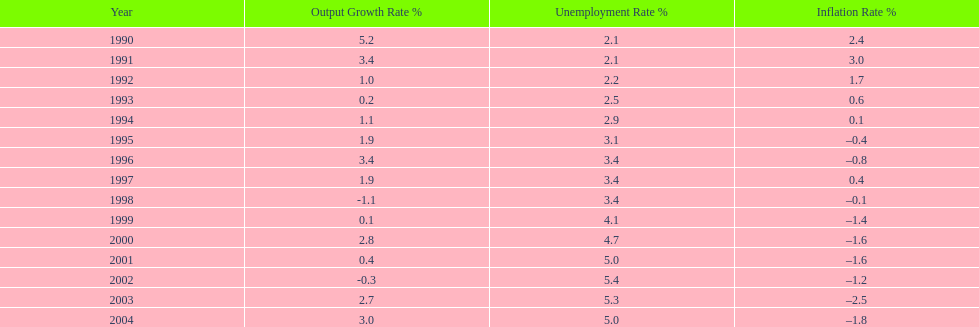What year saw the highest output growth rate in japan between the years 1990 and 2004? 1990. Parse the table in full. {'header': ['Year', 'Output Growth Rate\xa0%', 'Unemployment Rate\xa0%', 'Inflation Rate\xa0%'], 'rows': [['1990', '5.2', '2.1', '2.4'], ['1991', '3.4', '2.1', '3.0'], ['1992', '1.0', '2.2', '1.7'], ['1993', '0.2', '2.5', '0.6'], ['1994', '1.1', '2.9', '0.1'], ['1995', '1.9', '3.1', '–0.4'], ['1996', '3.4', '3.4', '–0.8'], ['1997', '1.9', '3.4', '0.4'], ['1998', '-1.1', '3.4', '–0.1'], ['1999', '0.1', '4.1', '–1.4'], ['2000', '2.8', '4.7', '–1.6'], ['2001', '0.4', '5.0', '–1.6'], ['2002', '-0.3', '5.4', '–1.2'], ['2003', '2.7', '5.3', '–2.5'], ['2004', '3.0', '5.0', '–1.8']]} 